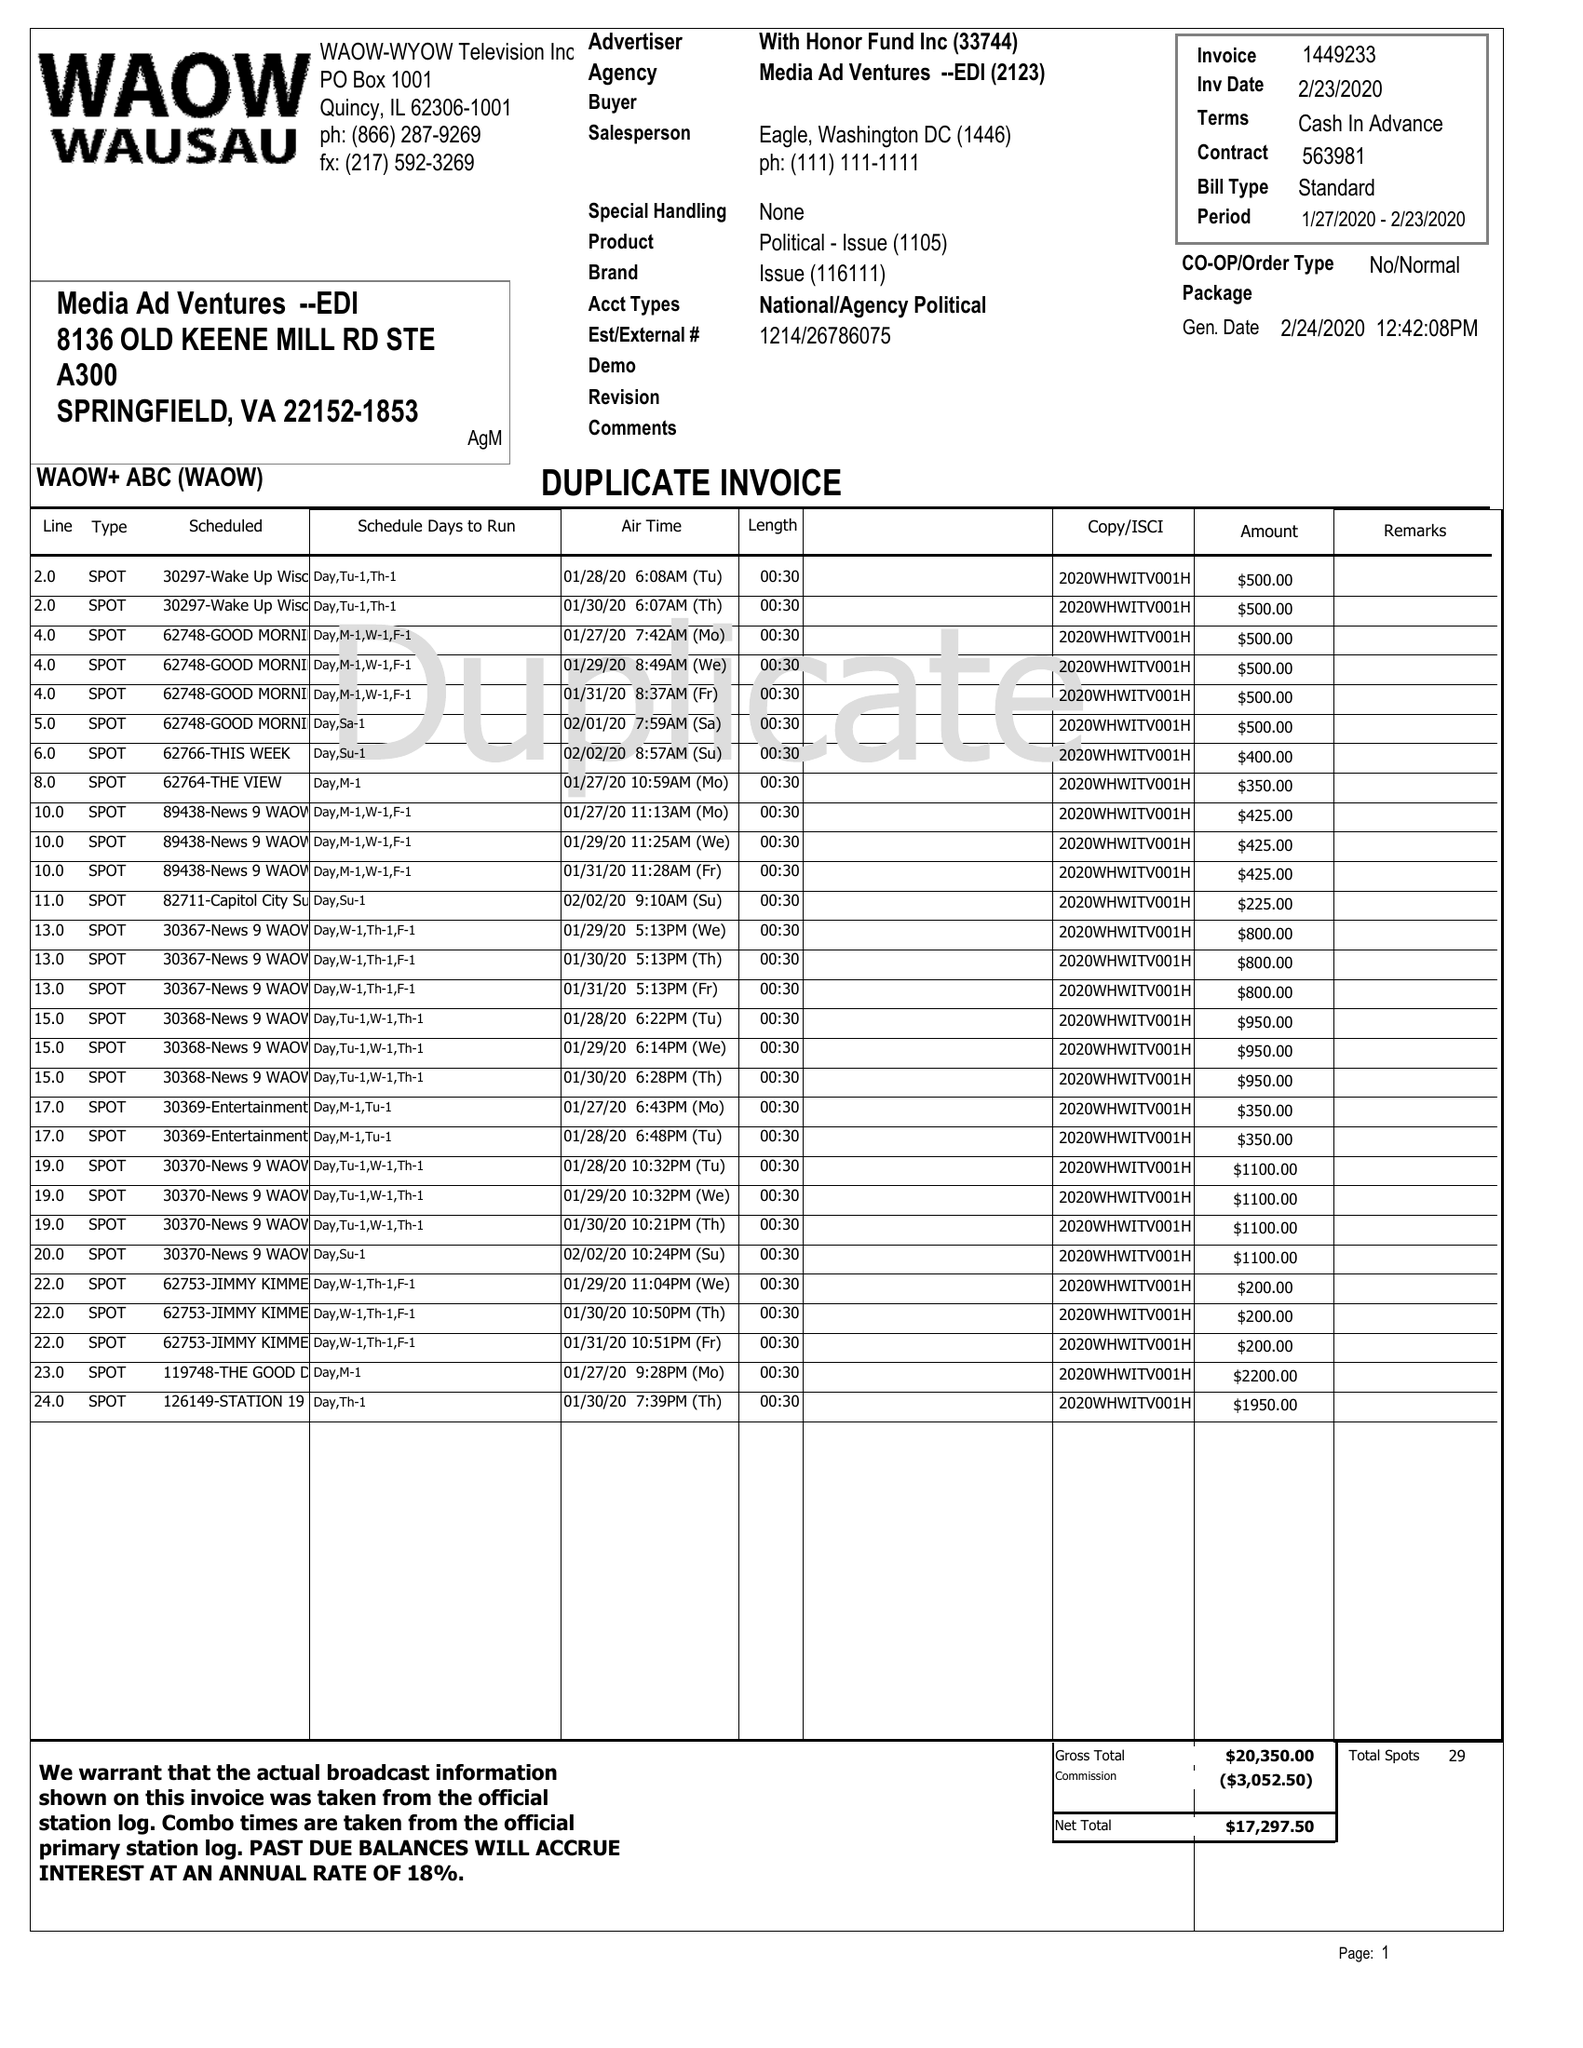What is the value for the gross_amount?
Answer the question using a single word or phrase. 87650.00 